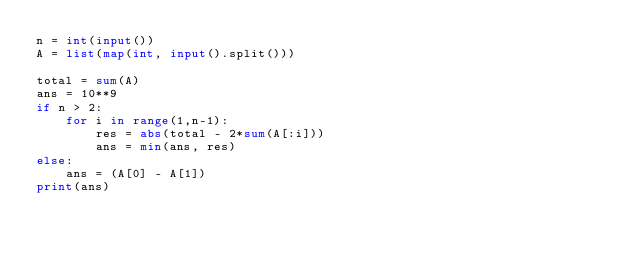<code> <loc_0><loc_0><loc_500><loc_500><_Python_>n = int(input())
A = list(map(int, input().split()))

total = sum(A)
ans = 10**9
if n > 2:
    for i in range(1,n-1):
        res = abs(total - 2*sum(A[:i]))
        ans = min(ans, res)
else:
    ans = (A[0] - A[1])
print(ans)
</code> 